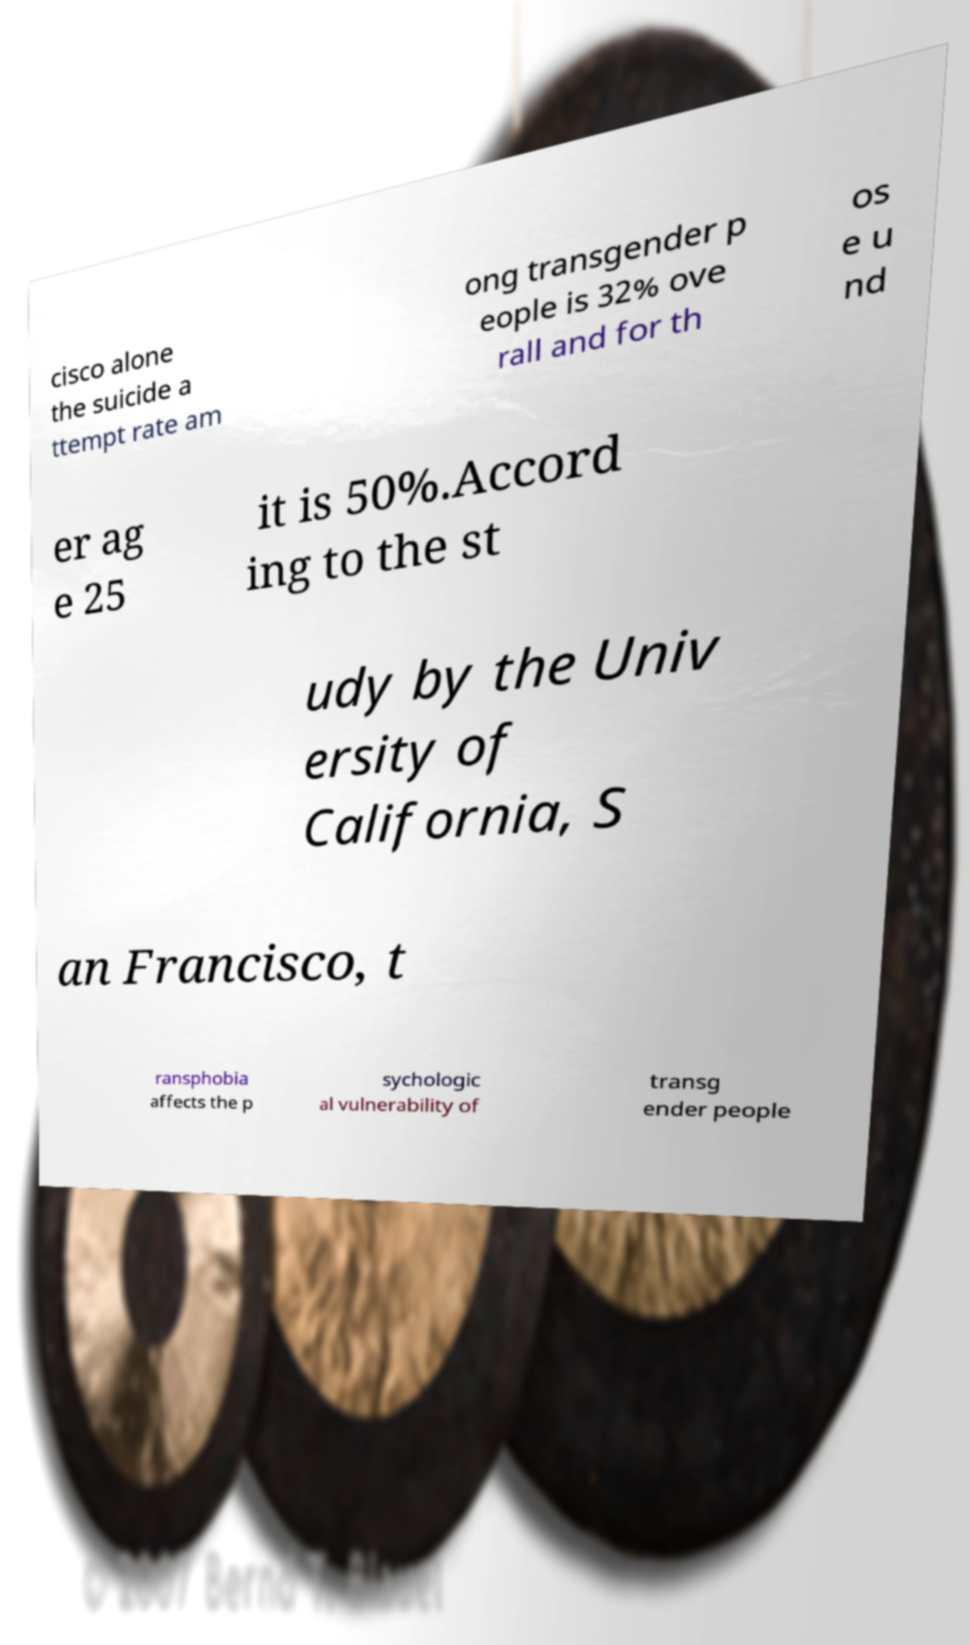Can you accurately transcribe the text from the provided image for me? cisco alone the suicide a ttempt rate am ong transgender p eople is 32% ove rall and for th os e u nd er ag e 25 it is 50%.Accord ing to the st udy by the Univ ersity of California, S an Francisco, t ransphobia affects the p sychologic al vulnerability of transg ender people 